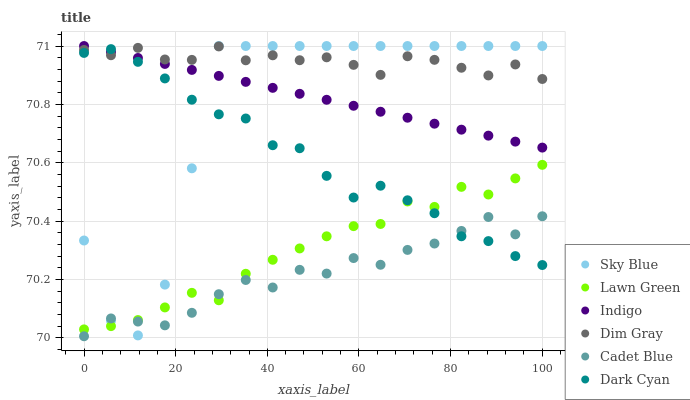Does Cadet Blue have the minimum area under the curve?
Answer yes or no. Yes. Does Dim Gray have the maximum area under the curve?
Answer yes or no. Yes. Does Indigo have the minimum area under the curve?
Answer yes or no. No. Does Indigo have the maximum area under the curve?
Answer yes or no. No. Is Indigo the smoothest?
Answer yes or no. Yes. Is Sky Blue the roughest?
Answer yes or no. Yes. Is Cadet Blue the smoothest?
Answer yes or no. No. Is Cadet Blue the roughest?
Answer yes or no. No. Does Cadet Blue have the lowest value?
Answer yes or no. Yes. Does Indigo have the lowest value?
Answer yes or no. No. Does Sky Blue have the highest value?
Answer yes or no. Yes. Does Cadet Blue have the highest value?
Answer yes or no. No. Is Cadet Blue less than Dim Gray?
Answer yes or no. Yes. Is Dim Gray greater than Cadet Blue?
Answer yes or no. Yes. Does Lawn Green intersect Dark Cyan?
Answer yes or no. Yes. Is Lawn Green less than Dark Cyan?
Answer yes or no. No. Is Lawn Green greater than Dark Cyan?
Answer yes or no. No. Does Cadet Blue intersect Dim Gray?
Answer yes or no. No. 